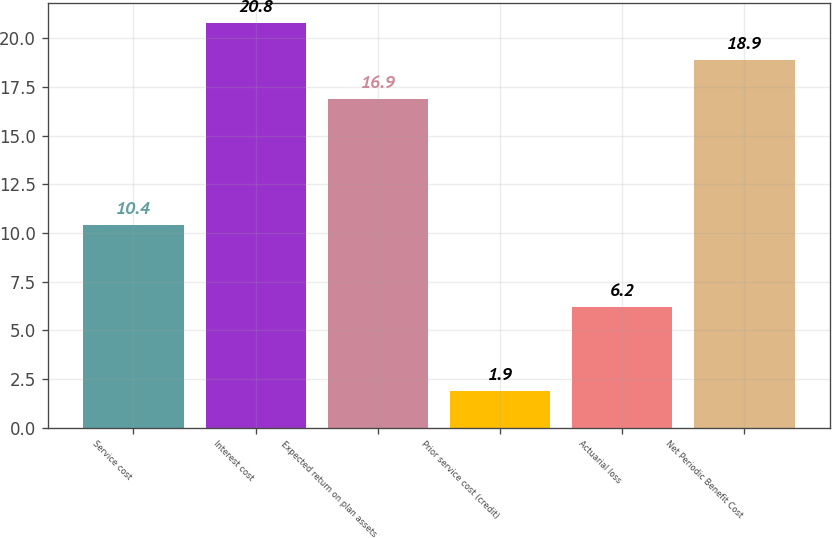Convert chart to OTSL. <chart><loc_0><loc_0><loc_500><loc_500><bar_chart><fcel>Service cost<fcel>Interest cost<fcel>Expected return on plan assets<fcel>Prior service cost (credit)<fcel>Actuarial loss<fcel>Net Periodic Benefit Cost<nl><fcel>10.4<fcel>20.8<fcel>16.9<fcel>1.9<fcel>6.2<fcel>18.9<nl></chart> 